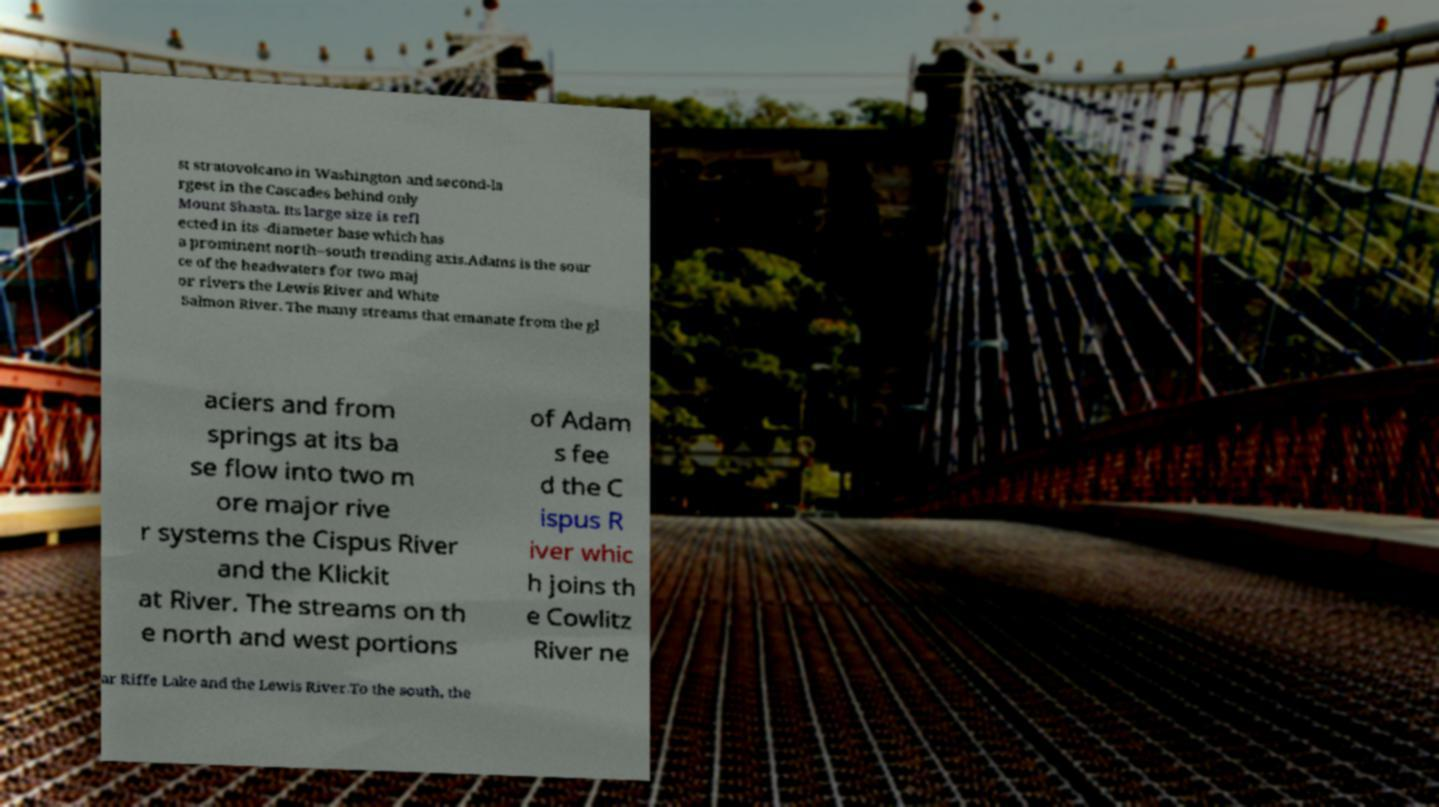I need the written content from this picture converted into text. Can you do that? st stratovolcano in Washington and second-la rgest in the Cascades behind only Mount Shasta. Its large size is refl ected in its -diameter base which has a prominent north–south trending axis.Adams is the sour ce of the headwaters for two maj or rivers the Lewis River and White Salmon River. The many streams that emanate from the gl aciers and from springs at its ba se flow into two m ore major rive r systems the Cispus River and the Klickit at River. The streams on th e north and west portions of Adam s fee d the C ispus R iver whic h joins th e Cowlitz River ne ar Riffe Lake and the Lewis River.To the south, the 